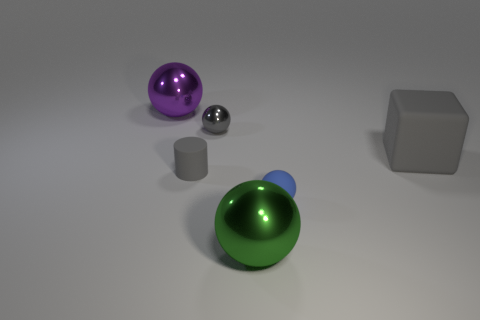Is there a green shiny ball that is in front of the big metal object in front of the big purple shiny ball? Indeed, there is a green shiny ball situated in front of a smaller metal cylinder, which in turn is in front of a larger purple shiny ball. 